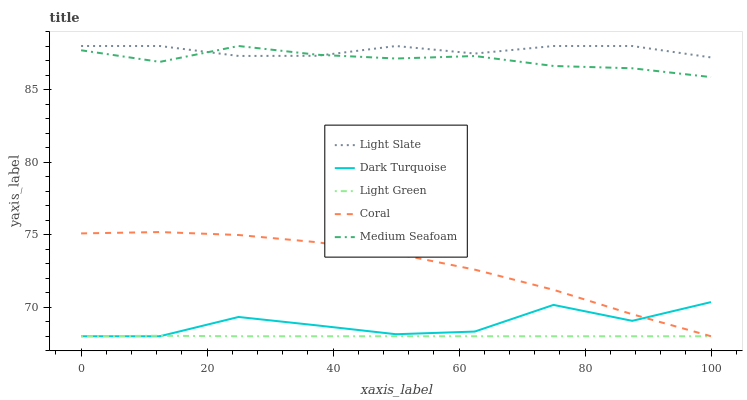Does Light Green have the minimum area under the curve?
Answer yes or no. Yes. Does Light Slate have the maximum area under the curve?
Answer yes or no. Yes. Does Dark Turquoise have the minimum area under the curve?
Answer yes or no. No. Does Dark Turquoise have the maximum area under the curve?
Answer yes or no. No. Is Light Green the smoothest?
Answer yes or no. Yes. Is Dark Turquoise the roughest?
Answer yes or no. Yes. Is Coral the smoothest?
Answer yes or no. No. Is Coral the roughest?
Answer yes or no. No. Does Medium Seafoam have the lowest value?
Answer yes or no. No. Does Dark Turquoise have the highest value?
Answer yes or no. No. Is Dark Turquoise less than Medium Seafoam?
Answer yes or no. Yes. Is Medium Seafoam greater than Coral?
Answer yes or no. Yes. Does Dark Turquoise intersect Medium Seafoam?
Answer yes or no. No. 